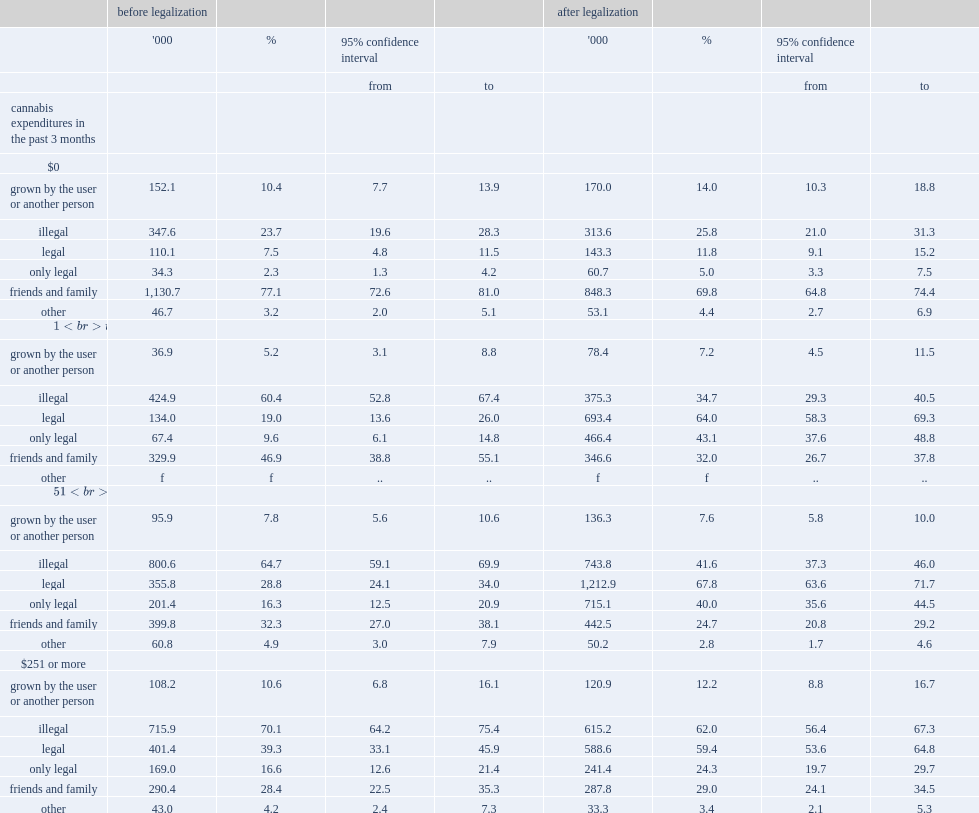Could you parse the entire table as a dict? {'header': ['', 'before legalization', '', '', '', 'after legalization', '', '', ''], 'rows': [['', "'000", '%', '95% confidence interval', '', "'000", '%', '95% confidence interval', ''], ['', '', '', 'from', 'to', '', '', 'from', 'to'], ['cannabis expenditures in the past 3 months', '', '', '', '', '', '', '', ''], ['$0', '', '', '', '', '', '', '', ''], ['grown by the user or another person', '152.1', '10.4', '7.7', '13.9', '170.0', '14.0', '10.3', '18.8'], ['illegal', '347.6', '23.7', '19.6', '28.3', '313.6', '25.8', '21.0', '31.3'], ['legal', '110.1', '7.5', '4.8', '11.5', '143.3', '11.8', '9.1', '15.2'], ['only legal', '34.3', '2.3', '1.3', '4.2', '60.7', '5.0', '3.3', '7.5'], ['friends and family', '1,130.7', '77.1', '72.6', '81.0', '848.3', '69.8', '64.8', '74.4'], ['other', '46.7', '3.2', '2.0', '5.1', '53.1', '4.4', '2.7', '6.9'], ['$1 to $50', '', '', '', '', '', '', '', ''], ['grown by the user or another person', '36.9', '5.2', '3.1', '8.8', '78.4', '7.2', '4.5', '11.5'], ['illegal', '424.9', '60.4', '52.8', '67.4', '375.3', '34.7', '29.3', '40.5'], ['legal', '134.0', '19.0', '13.6', '26.0', '693.4', '64.0', '58.3', '69.3'], ['only legal', '67.4', '9.6', '6.1', '14.8', '466.4', '43.1', '37.6', '48.8'], ['friends and family', '329.9', '46.9', '38.8', '55.1', '346.6', '32.0', '26.7', '37.8'], ['other', 'f', 'f', '..', '..', 'f', 'f', '..', '..'], ['$51 to $250', '', '', '', '', '', '', '', ''], ['grown by the user or another person', '95.9', '7.8', '5.6', '10.6', '136.3', '7.6', '5.8', '10.0'], ['illegal', '800.6', '64.7', '59.1', '69.9', '743.8', '41.6', '37.3', '46.0'], ['legal', '355.8', '28.8', '24.1', '34.0', '1,212.9', '67.8', '63.6', '71.7'], ['only legal', '201.4', '16.3', '12.5', '20.9', '715.1', '40.0', '35.6', '44.5'], ['friends and family', '399.8', '32.3', '27.0', '38.1', '442.5', '24.7', '20.8', '29.2'], ['other', '60.8', '4.9', '3.0', '7.9', '50.2', '2.8', '1.7', '4.6'], ['$251 or more', '', '', '', '', '', '', '', ''], ['grown by the user or another person', '108.2', '10.6', '6.8', '16.1', '120.9', '12.2', '8.8', '16.7'], ['illegal', '715.9', '70.1', '64.2', '75.4', '615.2', '62.0', '56.4', '67.3'], ['legal', '401.4', '39.3', '33.1', '45.9', '588.6', '59.4', '53.6', '64.8'], ['only legal', '169.0', '16.6', '12.6', '21.4', '241.4', '24.3', '19.7', '29.7'], ['friends and family', '290.4', '28.4', '22.5', '35.3', '287.8', '29.0', '24.1', '34.5'], ['other', '43.0', '4.2', '2.4', '7.3', '33.3', '3.4', '2.1', '5.3']]} How many percent of cannabis consumers who reported not paying have continued to report that they got at least some of their cannabis with family and friends in 2019 and in 2018, respectively? 77.1 69.8. Which source of cannabis by the highest spenders has decreased from 70.1% in 2018 to 62.0% in 2019? Illegal. 